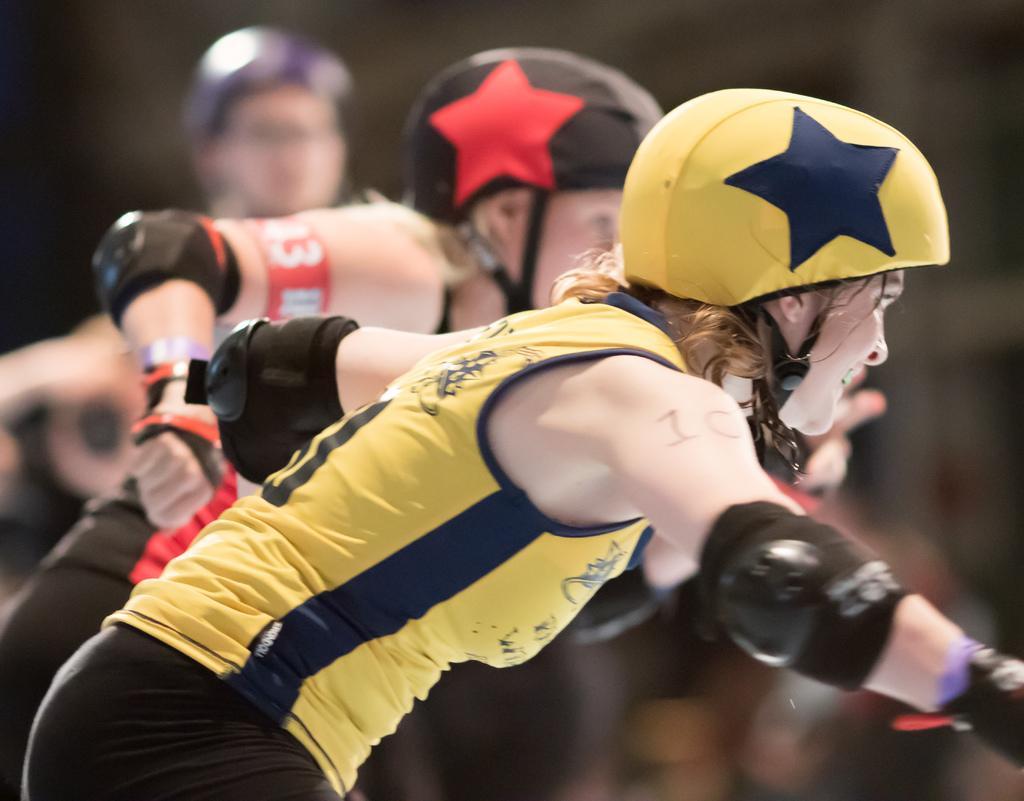In one or two sentences, can you explain what this image depicts? There are people wore helmets. In the background it is blur. 